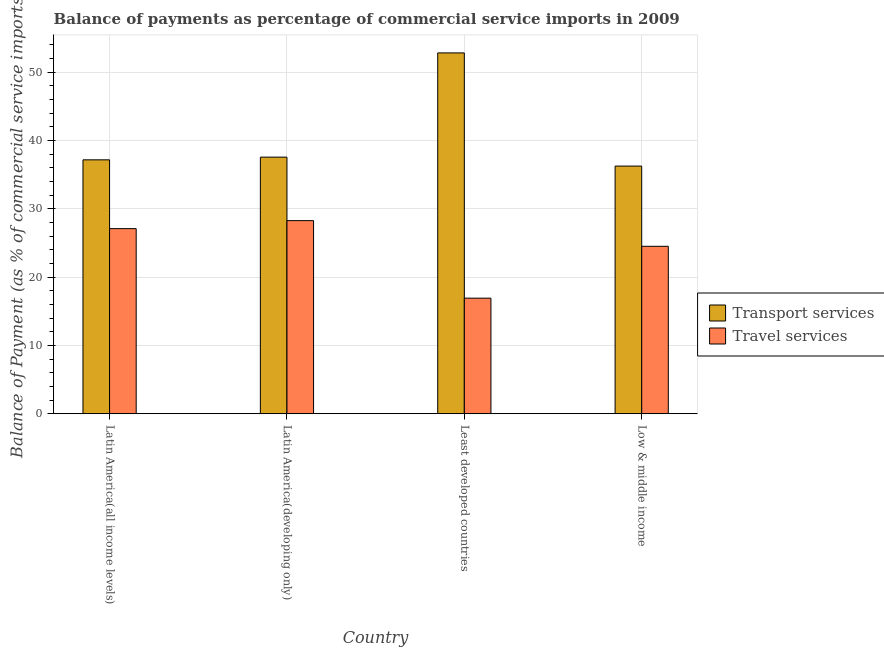How many groups of bars are there?
Your response must be concise. 4. Are the number of bars on each tick of the X-axis equal?
Your response must be concise. Yes. How many bars are there on the 1st tick from the left?
Your answer should be very brief. 2. What is the balance of payments of travel services in Latin America(developing only)?
Offer a terse response. 28.26. Across all countries, what is the maximum balance of payments of transport services?
Ensure brevity in your answer.  52.81. Across all countries, what is the minimum balance of payments of travel services?
Offer a terse response. 16.91. In which country was the balance of payments of transport services maximum?
Your response must be concise. Least developed countries. What is the total balance of payments of travel services in the graph?
Keep it short and to the point. 96.77. What is the difference between the balance of payments of travel services in Latin America(developing only) and that in Least developed countries?
Give a very brief answer. 11.35. What is the difference between the balance of payments of travel services in Latin America(all income levels) and the balance of payments of transport services in Low & middle income?
Offer a very short reply. -9.15. What is the average balance of payments of transport services per country?
Provide a short and direct response. 40.94. What is the difference between the balance of payments of travel services and balance of payments of transport services in Low & middle income?
Your response must be concise. -11.74. In how many countries, is the balance of payments of travel services greater than 50 %?
Ensure brevity in your answer.  0. What is the ratio of the balance of payments of travel services in Latin America(all income levels) to that in Low & middle income?
Your response must be concise. 1.11. What is the difference between the highest and the second highest balance of payments of transport services?
Provide a succinct answer. 15.25. What is the difference between the highest and the lowest balance of payments of travel services?
Ensure brevity in your answer.  11.35. In how many countries, is the balance of payments of transport services greater than the average balance of payments of transport services taken over all countries?
Give a very brief answer. 1. Is the sum of the balance of payments of travel services in Latin America(all income levels) and Least developed countries greater than the maximum balance of payments of transport services across all countries?
Provide a short and direct response. No. What does the 2nd bar from the left in Low & middle income represents?
Offer a terse response. Travel services. What does the 1st bar from the right in Low & middle income represents?
Make the answer very short. Travel services. How many bars are there?
Ensure brevity in your answer.  8. Are all the bars in the graph horizontal?
Offer a very short reply. No. How many countries are there in the graph?
Provide a succinct answer. 4. What is the difference between two consecutive major ticks on the Y-axis?
Your answer should be very brief. 10. Does the graph contain any zero values?
Keep it short and to the point. No. How many legend labels are there?
Keep it short and to the point. 2. How are the legend labels stacked?
Keep it short and to the point. Vertical. What is the title of the graph?
Offer a terse response. Balance of payments as percentage of commercial service imports in 2009. Does "Ages 15-24" appear as one of the legend labels in the graph?
Provide a succinct answer. No. What is the label or title of the X-axis?
Provide a short and direct response. Country. What is the label or title of the Y-axis?
Give a very brief answer. Balance of Payment (as % of commercial service imports). What is the Balance of Payment (as % of commercial service imports) in Transport services in Latin America(all income levels)?
Ensure brevity in your answer.  37.16. What is the Balance of Payment (as % of commercial service imports) of Travel services in Latin America(all income levels)?
Provide a short and direct response. 27.09. What is the Balance of Payment (as % of commercial service imports) of Transport services in Latin America(developing only)?
Your answer should be compact. 37.55. What is the Balance of Payment (as % of commercial service imports) of Travel services in Latin America(developing only)?
Your answer should be very brief. 28.26. What is the Balance of Payment (as % of commercial service imports) of Transport services in Least developed countries?
Make the answer very short. 52.81. What is the Balance of Payment (as % of commercial service imports) in Travel services in Least developed countries?
Provide a succinct answer. 16.91. What is the Balance of Payment (as % of commercial service imports) in Transport services in Low & middle income?
Keep it short and to the point. 36.24. What is the Balance of Payment (as % of commercial service imports) of Travel services in Low & middle income?
Provide a short and direct response. 24.5. Across all countries, what is the maximum Balance of Payment (as % of commercial service imports) in Transport services?
Provide a succinct answer. 52.81. Across all countries, what is the maximum Balance of Payment (as % of commercial service imports) of Travel services?
Give a very brief answer. 28.26. Across all countries, what is the minimum Balance of Payment (as % of commercial service imports) of Transport services?
Keep it short and to the point. 36.24. Across all countries, what is the minimum Balance of Payment (as % of commercial service imports) in Travel services?
Give a very brief answer. 16.91. What is the total Balance of Payment (as % of commercial service imports) in Transport services in the graph?
Make the answer very short. 163.76. What is the total Balance of Payment (as % of commercial service imports) of Travel services in the graph?
Provide a succinct answer. 96.77. What is the difference between the Balance of Payment (as % of commercial service imports) of Transport services in Latin America(all income levels) and that in Latin America(developing only)?
Your answer should be compact. -0.4. What is the difference between the Balance of Payment (as % of commercial service imports) of Travel services in Latin America(all income levels) and that in Latin America(developing only)?
Your answer should be very brief. -1.17. What is the difference between the Balance of Payment (as % of commercial service imports) in Transport services in Latin America(all income levels) and that in Least developed countries?
Ensure brevity in your answer.  -15.65. What is the difference between the Balance of Payment (as % of commercial service imports) in Travel services in Latin America(all income levels) and that in Least developed countries?
Offer a terse response. 10.18. What is the difference between the Balance of Payment (as % of commercial service imports) of Transport services in Latin America(all income levels) and that in Low & middle income?
Give a very brief answer. 0.91. What is the difference between the Balance of Payment (as % of commercial service imports) of Travel services in Latin America(all income levels) and that in Low & middle income?
Provide a succinct answer. 2.59. What is the difference between the Balance of Payment (as % of commercial service imports) of Transport services in Latin America(developing only) and that in Least developed countries?
Offer a very short reply. -15.25. What is the difference between the Balance of Payment (as % of commercial service imports) of Travel services in Latin America(developing only) and that in Least developed countries?
Your answer should be compact. 11.35. What is the difference between the Balance of Payment (as % of commercial service imports) of Transport services in Latin America(developing only) and that in Low & middle income?
Your response must be concise. 1.31. What is the difference between the Balance of Payment (as % of commercial service imports) of Travel services in Latin America(developing only) and that in Low & middle income?
Your answer should be very brief. 3.76. What is the difference between the Balance of Payment (as % of commercial service imports) of Transport services in Least developed countries and that in Low & middle income?
Ensure brevity in your answer.  16.56. What is the difference between the Balance of Payment (as % of commercial service imports) in Travel services in Least developed countries and that in Low & middle income?
Your answer should be very brief. -7.59. What is the difference between the Balance of Payment (as % of commercial service imports) in Transport services in Latin America(all income levels) and the Balance of Payment (as % of commercial service imports) in Travel services in Latin America(developing only)?
Offer a very short reply. 8.9. What is the difference between the Balance of Payment (as % of commercial service imports) in Transport services in Latin America(all income levels) and the Balance of Payment (as % of commercial service imports) in Travel services in Least developed countries?
Keep it short and to the point. 20.24. What is the difference between the Balance of Payment (as % of commercial service imports) of Transport services in Latin America(all income levels) and the Balance of Payment (as % of commercial service imports) of Travel services in Low & middle income?
Your response must be concise. 12.65. What is the difference between the Balance of Payment (as % of commercial service imports) in Transport services in Latin America(developing only) and the Balance of Payment (as % of commercial service imports) in Travel services in Least developed countries?
Provide a short and direct response. 20.64. What is the difference between the Balance of Payment (as % of commercial service imports) of Transport services in Latin America(developing only) and the Balance of Payment (as % of commercial service imports) of Travel services in Low & middle income?
Your answer should be very brief. 13.05. What is the difference between the Balance of Payment (as % of commercial service imports) of Transport services in Least developed countries and the Balance of Payment (as % of commercial service imports) of Travel services in Low & middle income?
Ensure brevity in your answer.  28.3. What is the average Balance of Payment (as % of commercial service imports) of Transport services per country?
Offer a very short reply. 40.94. What is the average Balance of Payment (as % of commercial service imports) in Travel services per country?
Your answer should be very brief. 24.19. What is the difference between the Balance of Payment (as % of commercial service imports) of Transport services and Balance of Payment (as % of commercial service imports) of Travel services in Latin America(all income levels)?
Make the answer very short. 10.07. What is the difference between the Balance of Payment (as % of commercial service imports) of Transport services and Balance of Payment (as % of commercial service imports) of Travel services in Latin America(developing only)?
Offer a terse response. 9.29. What is the difference between the Balance of Payment (as % of commercial service imports) of Transport services and Balance of Payment (as % of commercial service imports) of Travel services in Least developed countries?
Give a very brief answer. 35.89. What is the difference between the Balance of Payment (as % of commercial service imports) of Transport services and Balance of Payment (as % of commercial service imports) of Travel services in Low & middle income?
Provide a short and direct response. 11.74. What is the ratio of the Balance of Payment (as % of commercial service imports) of Transport services in Latin America(all income levels) to that in Latin America(developing only)?
Offer a terse response. 0.99. What is the ratio of the Balance of Payment (as % of commercial service imports) of Travel services in Latin America(all income levels) to that in Latin America(developing only)?
Offer a very short reply. 0.96. What is the ratio of the Balance of Payment (as % of commercial service imports) of Transport services in Latin America(all income levels) to that in Least developed countries?
Provide a succinct answer. 0.7. What is the ratio of the Balance of Payment (as % of commercial service imports) of Travel services in Latin America(all income levels) to that in Least developed countries?
Make the answer very short. 1.6. What is the ratio of the Balance of Payment (as % of commercial service imports) in Transport services in Latin America(all income levels) to that in Low & middle income?
Your answer should be compact. 1.03. What is the ratio of the Balance of Payment (as % of commercial service imports) of Travel services in Latin America(all income levels) to that in Low & middle income?
Your answer should be compact. 1.11. What is the ratio of the Balance of Payment (as % of commercial service imports) in Transport services in Latin America(developing only) to that in Least developed countries?
Keep it short and to the point. 0.71. What is the ratio of the Balance of Payment (as % of commercial service imports) of Travel services in Latin America(developing only) to that in Least developed countries?
Your response must be concise. 1.67. What is the ratio of the Balance of Payment (as % of commercial service imports) of Transport services in Latin America(developing only) to that in Low & middle income?
Make the answer very short. 1.04. What is the ratio of the Balance of Payment (as % of commercial service imports) in Travel services in Latin America(developing only) to that in Low & middle income?
Offer a terse response. 1.15. What is the ratio of the Balance of Payment (as % of commercial service imports) of Transport services in Least developed countries to that in Low & middle income?
Offer a very short reply. 1.46. What is the ratio of the Balance of Payment (as % of commercial service imports) of Travel services in Least developed countries to that in Low & middle income?
Your answer should be compact. 0.69. What is the difference between the highest and the second highest Balance of Payment (as % of commercial service imports) of Transport services?
Offer a terse response. 15.25. What is the difference between the highest and the second highest Balance of Payment (as % of commercial service imports) in Travel services?
Keep it short and to the point. 1.17. What is the difference between the highest and the lowest Balance of Payment (as % of commercial service imports) in Transport services?
Offer a very short reply. 16.56. What is the difference between the highest and the lowest Balance of Payment (as % of commercial service imports) of Travel services?
Make the answer very short. 11.35. 